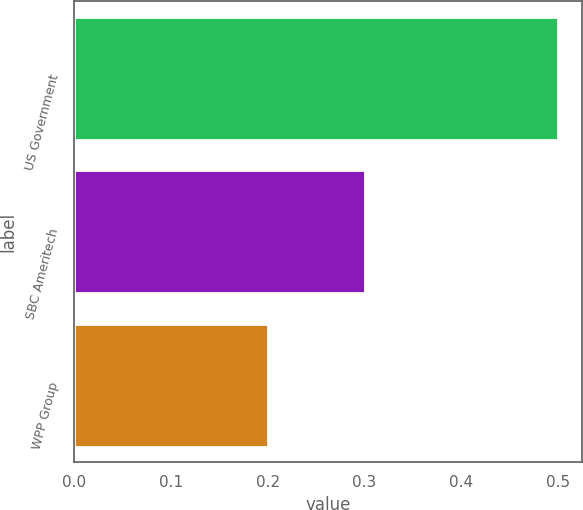<chart> <loc_0><loc_0><loc_500><loc_500><bar_chart><fcel>US Government<fcel>SBC Ameritech<fcel>WPP Group<nl><fcel>0.5<fcel>0.3<fcel>0.2<nl></chart> 